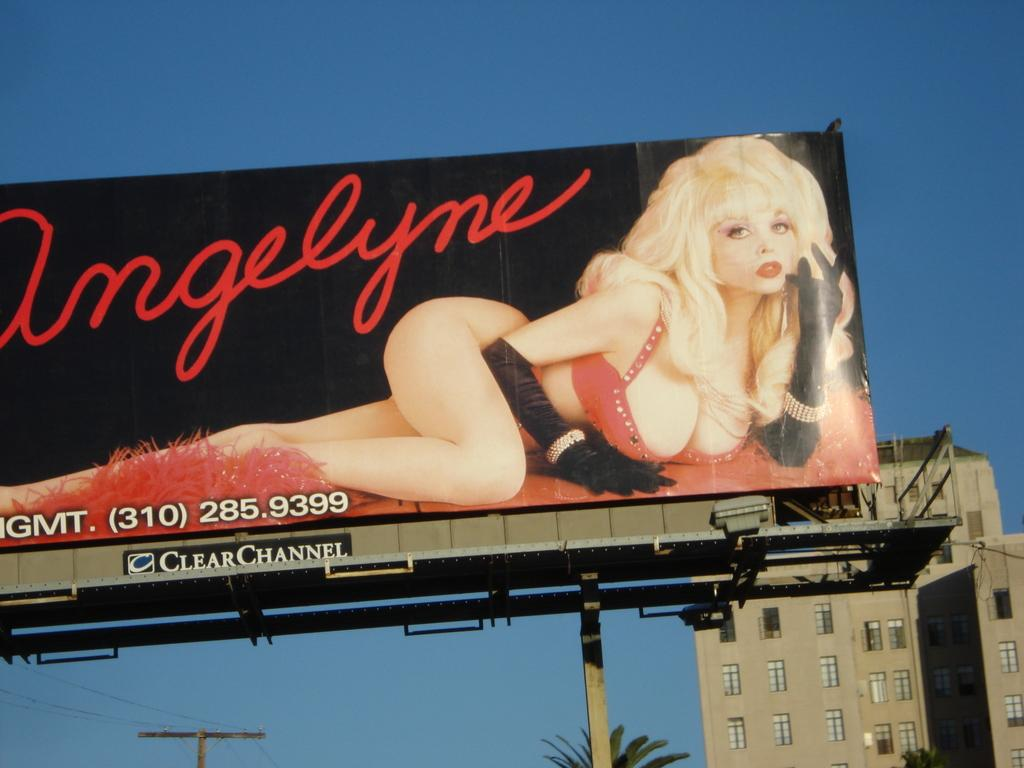What is the main subject of the image? The main subject of the image is a hoarding. What can be seen on the hoarding? There is a picture of a woman and text on the hoarding. What can be seen in the background of the image? There is a building, a tree, a pole, and the sky in the background of the image. What color is the sky in the image? The sky is blue in the background of the image. Can you see any airplanes flying in the sky in the image? There are no airplanes visible in the sky in the image. What type of knot is being used to secure the hoarding to the pole in the image? There is no knot visible in the image, as the hoarding is not shown to be secured to the pole. 